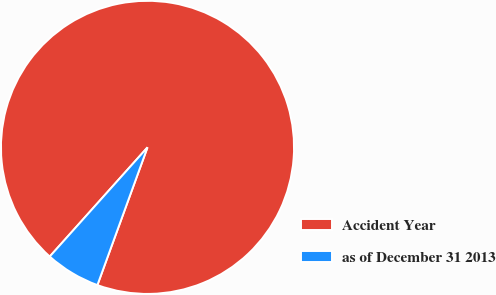Convert chart. <chart><loc_0><loc_0><loc_500><loc_500><pie_chart><fcel>Accident Year<fcel>as of December 31 2013<nl><fcel>93.93%<fcel>6.07%<nl></chart> 